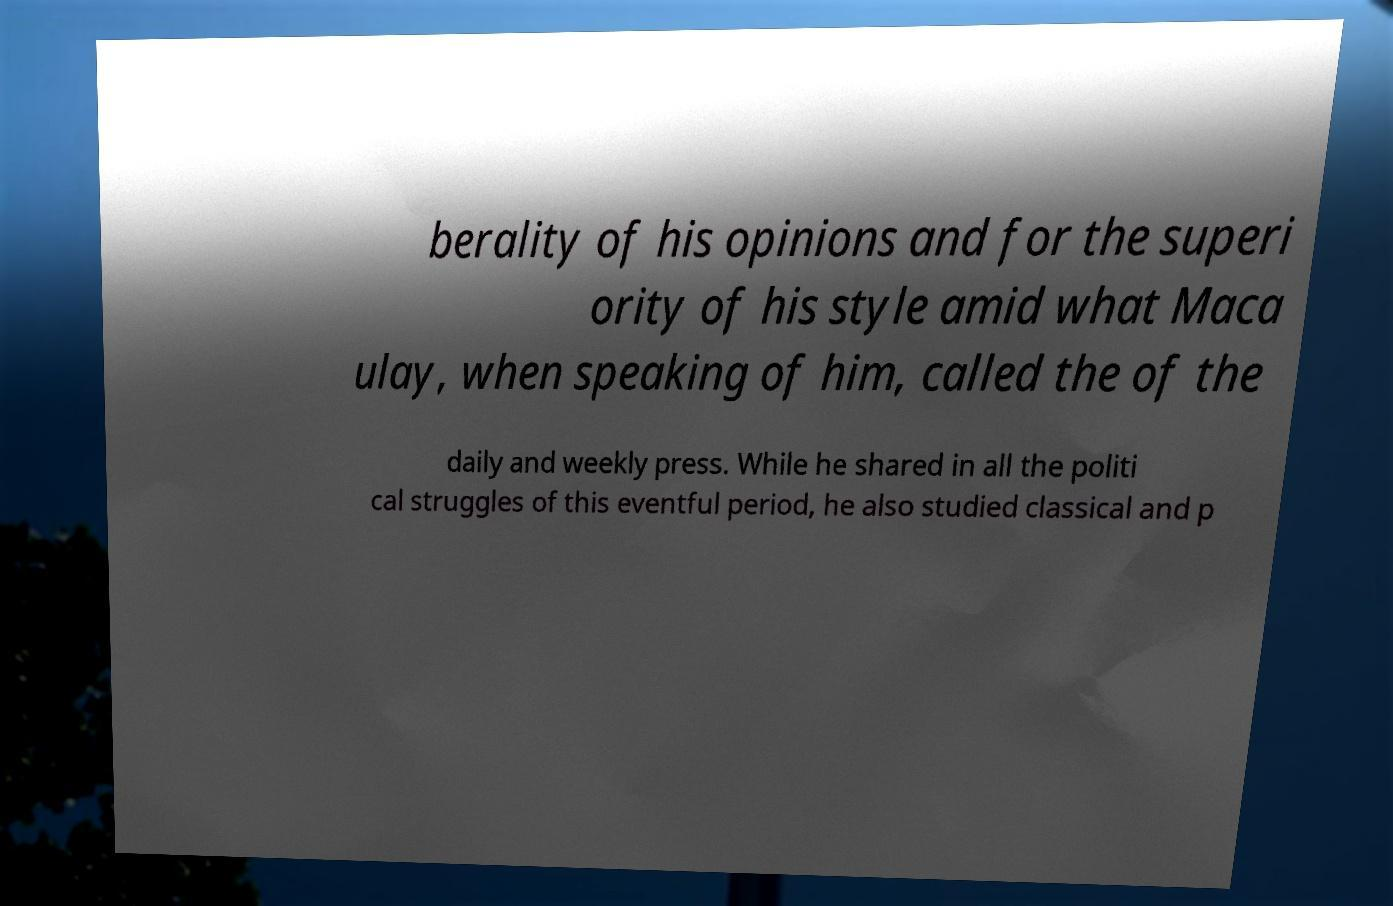I need the written content from this picture converted into text. Can you do that? berality of his opinions and for the superi ority of his style amid what Maca ulay, when speaking of him, called the of the daily and weekly press. While he shared in all the politi cal struggles of this eventful period, he also studied classical and p 